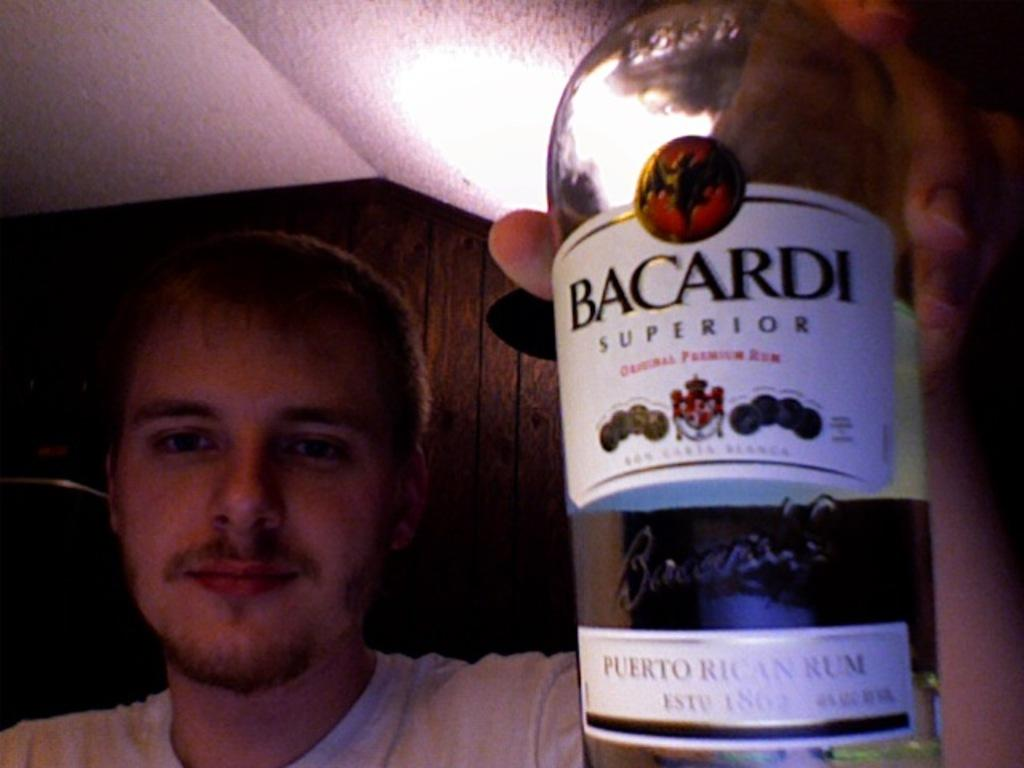Provide a one-sentence caption for the provided image. A man holding a bottle of rum up with a label that says on Bacardi Superior on it. 